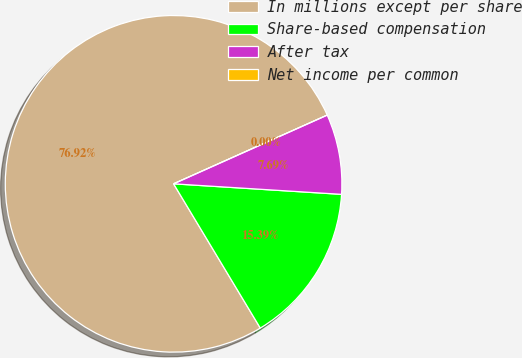Convert chart. <chart><loc_0><loc_0><loc_500><loc_500><pie_chart><fcel>In millions except per share<fcel>Share-based compensation<fcel>After tax<fcel>Net income per common<nl><fcel>76.92%<fcel>15.39%<fcel>7.69%<fcel>0.0%<nl></chart> 